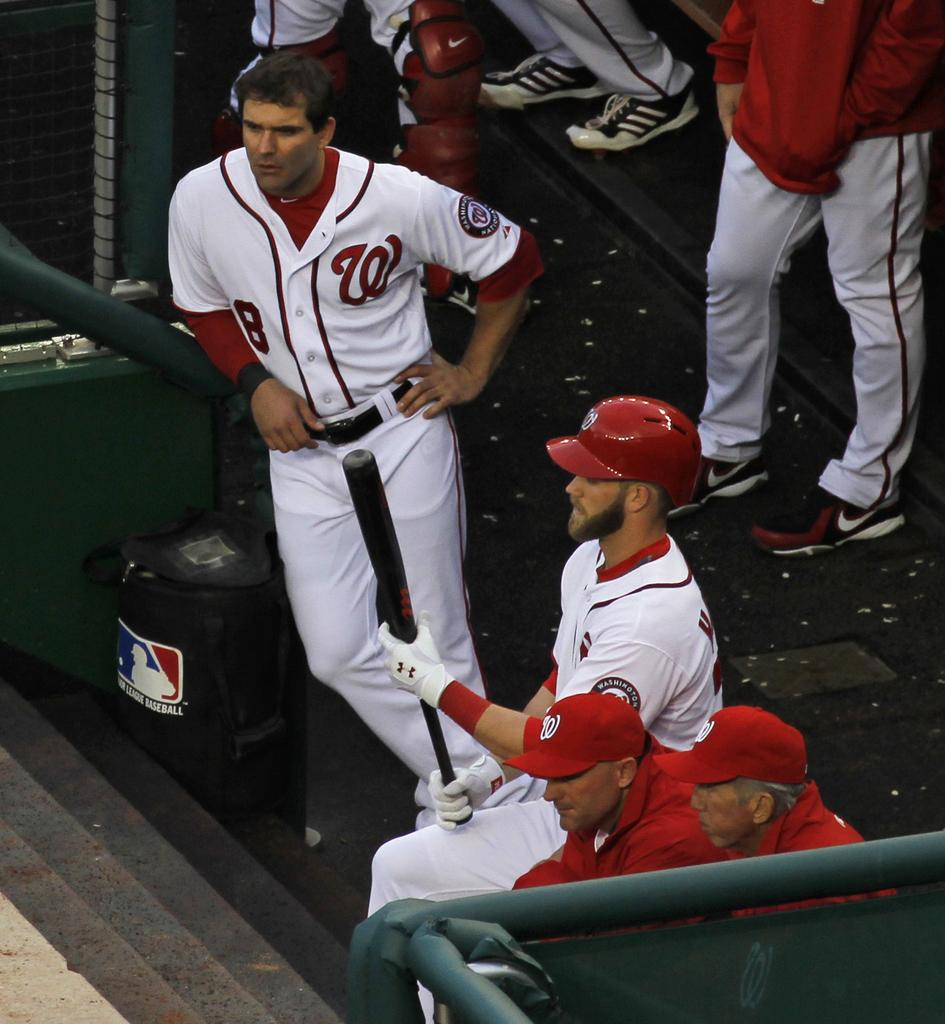<image>
Give a short and clear explanation of the subsequent image. a man standing next to another one with a W on his shirt 